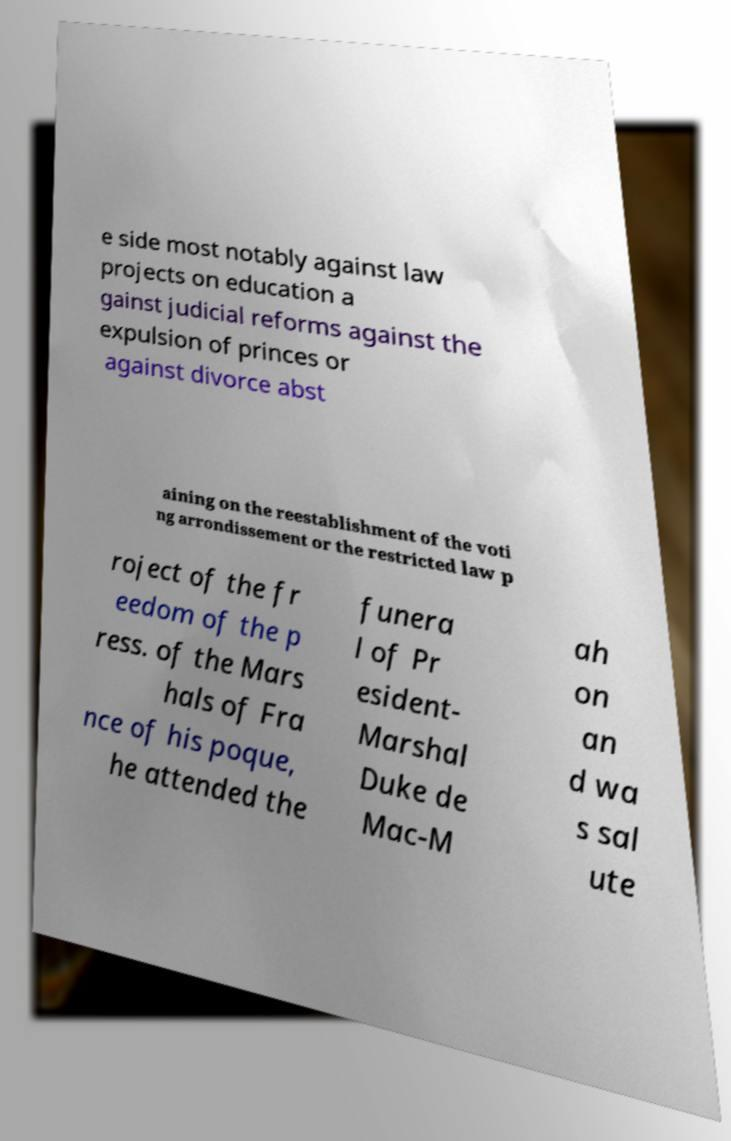What messages or text are displayed in this image? I need them in a readable, typed format. e side most notably against law projects on education a gainst judicial reforms against the expulsion of princes or against divorce abst aining on the reestablishment of the voti ng arrondissement or the restricted law p roject of the fr eedom of the p ress. of the Mars hals of Fra nce of his poque, he attended the funera l of Pr esident- Marshal Duke de Mac-M ah on an d wa s sal ute 